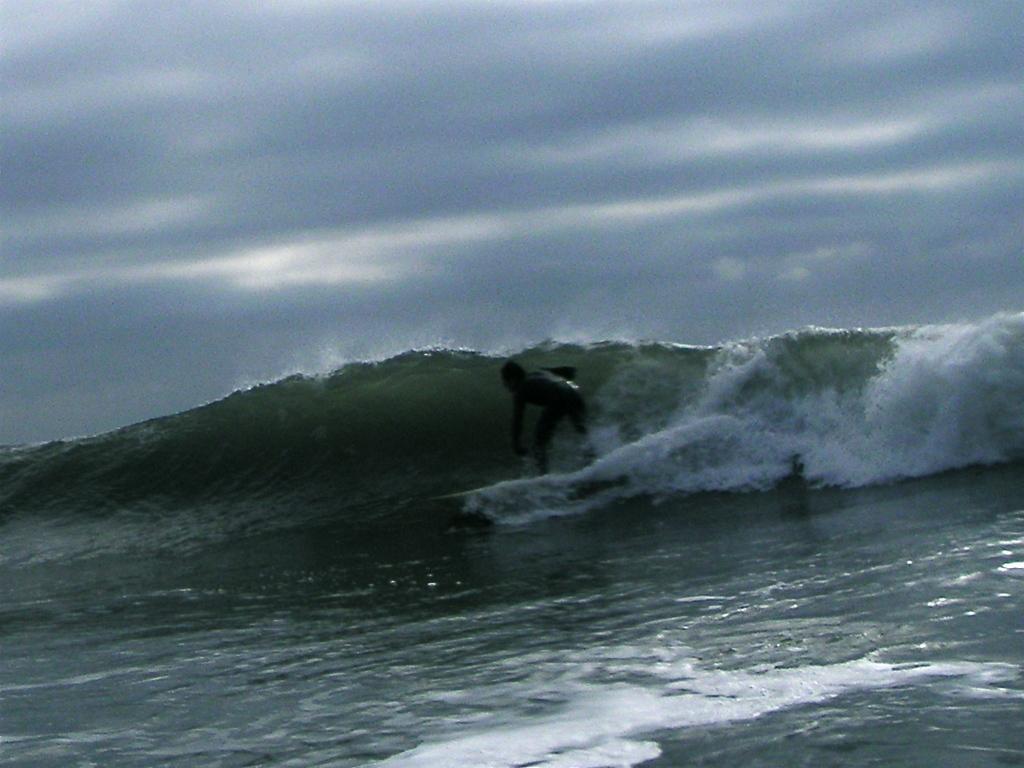Please provide a concise description of this image. In this picture there is a person surfing on the water with surfboard. In the background of the image we can see the sky. 